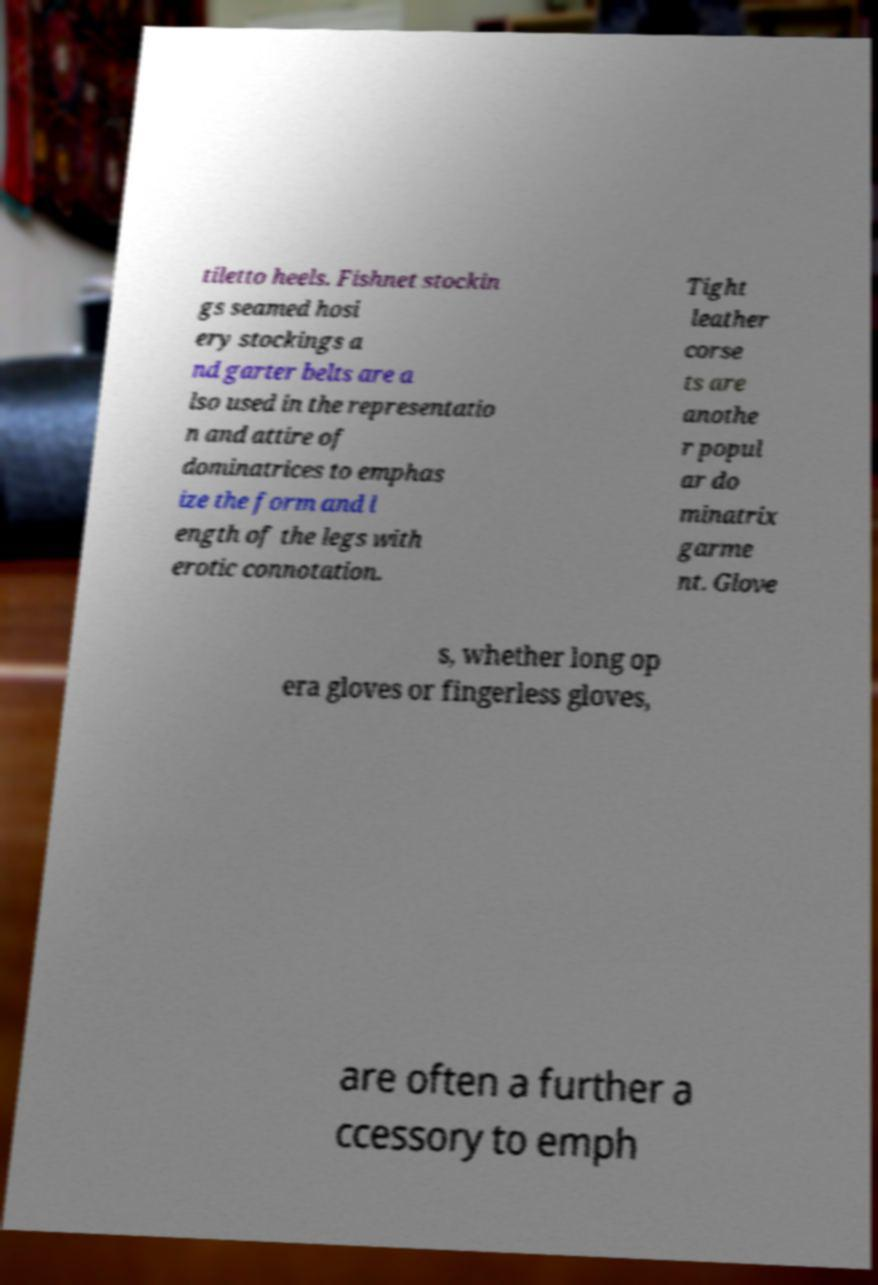Could you extract and type out the text from this image? tiletto heels. Fishnet stockin gs seamed hosi ery stockings a nd garter belts are a lso used in the representatio n and attire of dominatrices to emphas ize the form and l ength of the legs with erotic connotation. Tight leather corse ts are anothe r popul ar do minatrix garme nt. Glove s, whether long op era gloves or fingerless gloves, are often a further a ccessory to emph 